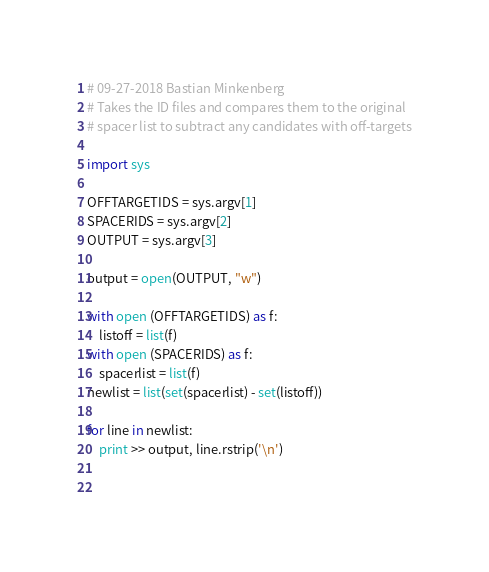Convert code to text. <code><loc_0><loc_0><loc_500><loc_500><_Python_># 09-27-2018 Bastian Minkenberg
# Takes the ID files and compares them to the original
# spacer list to subtract any candidates with off-targets

import sys

OFFTARGETIDS = sys.argv[1]
SPACERIDS = sys.argv[2]
OUTPUT = sys.argv[3]

output = open(OUTPUT, "w")

with open (OFFTARGETIDS) as f:
    listoff = list(f)
with open (SPACERIDS) as f:
    spacerlist = list(f)
newlist = list(set(spacerlist) - set(listoff))

for line in newlist:
    print >> output, line.rstrip('\n')

        
</code> 